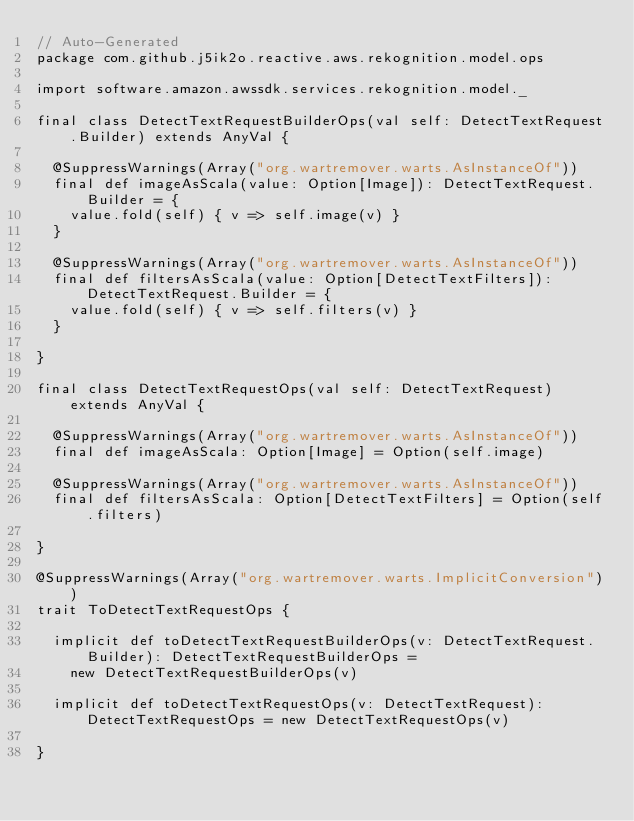<code> <loc_0><loc_0><loc_500><loc_500><_Scala_>// Auto-Generated
package com.github.j5ik2o.reactive.aws.rekognition.model.ops

import software.amazon.awssdk.services.rekognition.model._

final class DetectTextRequestBuilderOps(val self: DetectTextRequest.Builder) extends AnyVal {

  @SuppressWarnings(Array("org.wartremover.warts.AsInstanceOf"))
  final def imageAsScala(value: Option[Image]): DetectTextRequest.Builder = {
    value.fold(self) { v => self.image(v) }
  }

  @SuppressWarnings(Array("org.wartremover.warts.AsInstanceOf"))
  final def filtersAsScala(value: Option[DetectTextFilters]): DetectTextRequest.Builder = {
    value.fold(self) { v => self.filters(v) }
  }

}

final class DetectTextRequestOps(val self: DetectTextRequest) extends AnyVal {

  @SuppressWarnings(Array("org.wartremover.warts.AsInstanceOf"))
  final def imageAsScala: Option[Image] = Option(self.image)

  @SuppressWarnings(Array("org.wartremover.warts.AsInstanceOf"))
  final def filtersAsScala: Option[DetectTextFilters] = Option(self.filters)

}

@SuppressWarnings(Array("org.wartremover.warts.ImplicitConversion"))
trait ToDetectTextRequestOps {

  implicit def toDetectTextRequestBuilderOps(v: DetectTextRequest.Builder): DetectTextRequestBuilderOps =
    new DetectTextRequestBuilderOps(v)

  implicit def toDetectTextRequestOps(v: DetectTextRequest): DetectTextRequestOps = new DetectTextRequestOps(v)

}
</code> 